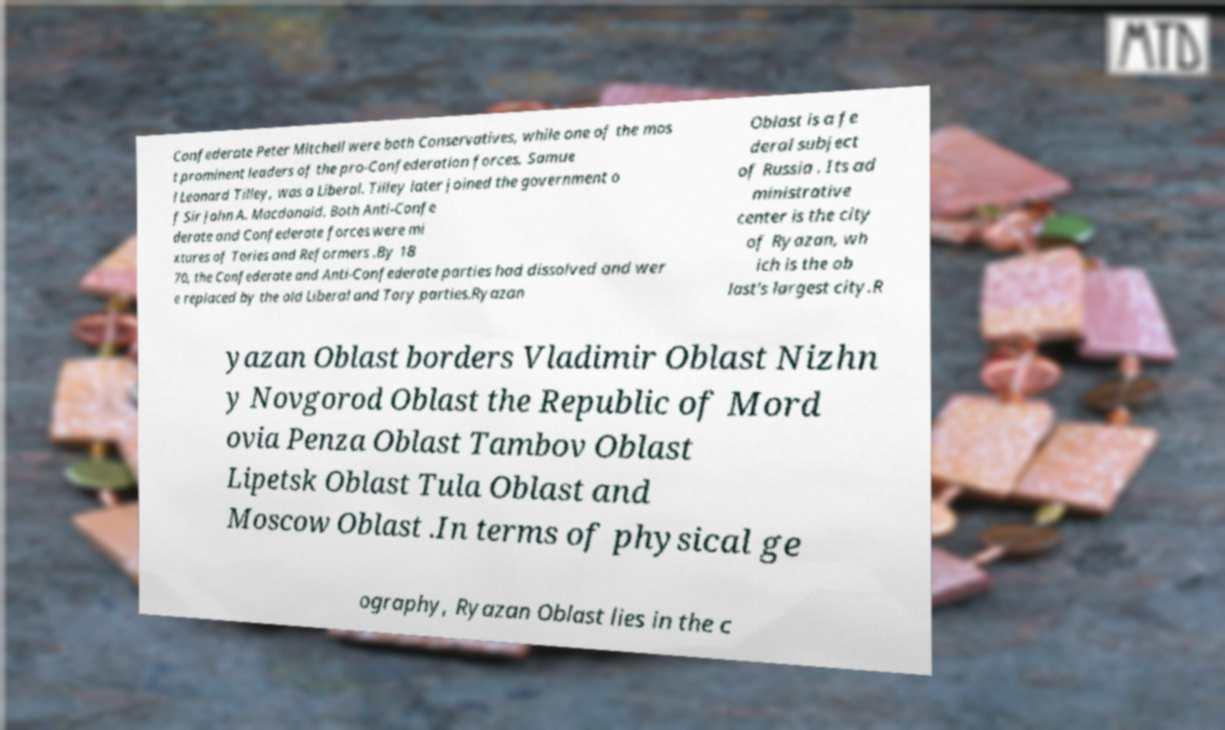I need the written content from this picture converted into text. Can you do that? Confederate Peter Mitchell were both Conservatives, while one of the mos t prominent leaders of the pro-Confederation forces, Samue l Leonard Tilley, was a Liberal. Tilley later joined the government o f Sir John A. Macdonald. Both Anti-Confe derate and Confederate forces were mi xtures of Tories and Reformers .By 18 70, the Confederate and Anti-Confederate parties had dissolved and wer e replaced by the old Liberal and Tory parties.Ryazan Oblast is a fe deral subject of Russia . Its ad ministrative center is the city of Ryazan, wh ich is the ob last's largest city.R yazan Oblast borders Vladimir Oblast Nizhn y Novgorod Oblast the Republic of Mord ovia Penza Oblast Tambov Oblast Lipetsk Oblast Tula Oblast and Moscow Oblast .In terms of physical ge ography, Ryazan Oblast lies in the c 